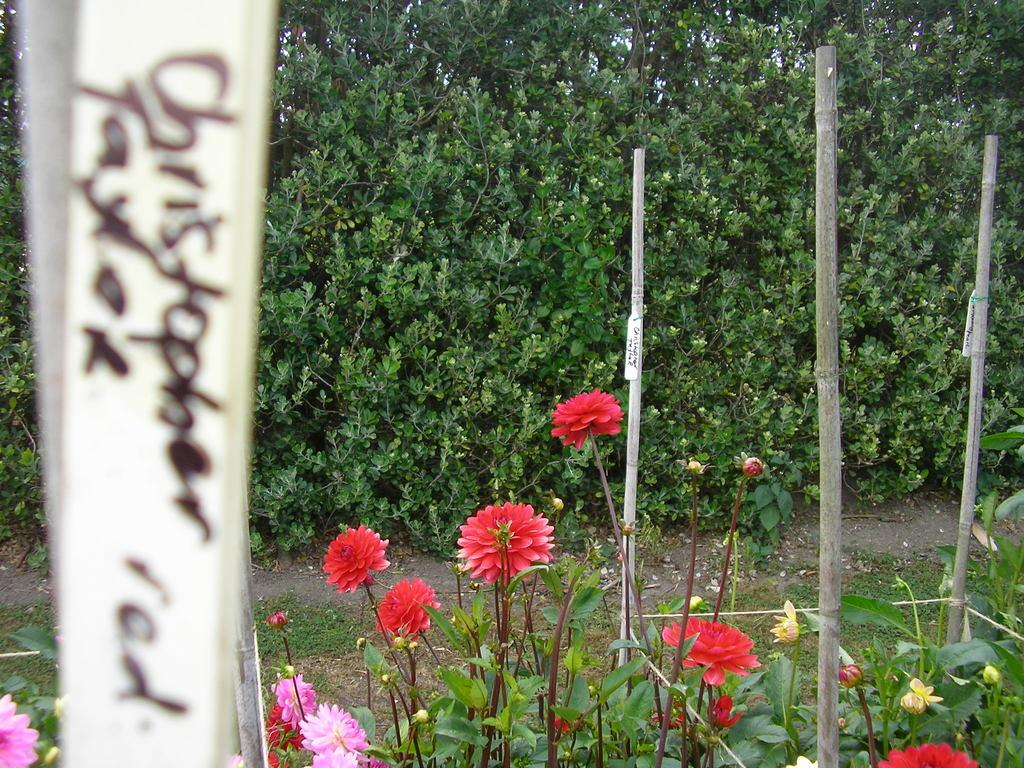What types of plants are in the foreground of the image? There are flowering plants and trees in the foreground of the image. What other objects can be seen in the foreground of the image? There are bamboo sticks in the foreground of the image. Can you describe the setting of the image? The image may have been taken in a farm, based on the presence of plants and trees. What type of cracker is being used to hold the bamboo sticks together in the image? There is no cracker present in the image, and the bamboo sticks are not being held together by any object. 